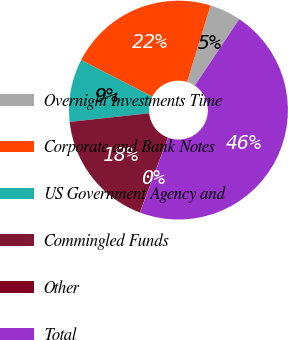Convert chart to OTSL. <chart><loc_0><loc_0><loc_500><loc_500><pie_chart><fcel>Overnight Investments Time<fcel>Corporate and Bank Notes<fcel>US Government Agency and<fcel>Commingled Funds<fcel>Other<fcel>Total<nl><fcel>4.65%<fcel>22.17%<fcel>9.28%<fcel>17.54%<fcel>0.01%<fcel>46.35%<nl></chart> 